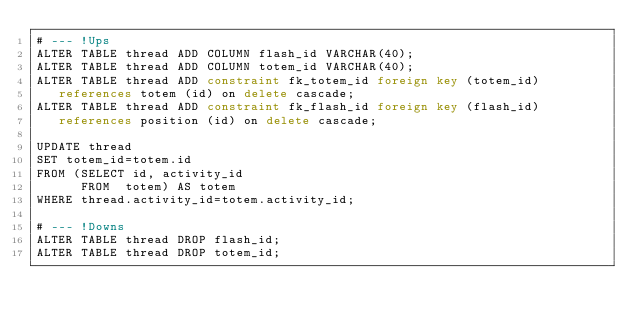<code> <loc_0><loc_0><loc_500><loc_500><_SQL_># --- !Ups
ALTER TABLE thread ADD COLUMN flash_id VARCHAR(40);
ALTER TABLE thread ADD COLUMN totem_id VARCHAR(40);
ALTER TABLE thread ADD constraint fk_totem_id foreign key (totem_id)
   references totem (id) on delete cascade;
ALTER TABLE thread ADD constraint fk_flash_id foreign key (flash_id)
   references position (id) on delete cascade;

UPDATE thread
SET totem_id=totem.id
FROM (SELECT id, activity_id
      FROM  totem) AS totem
WHERE thread.activity_id=totem.activity_id;

# --- !Downs
ALTER TABLE thread DROP flash_id;
ALTER TABLE thread DROP totem_id;
</code> 